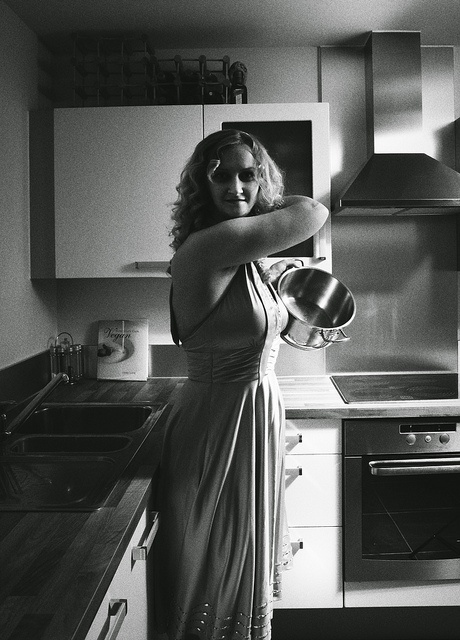Describe the objects in this image and their specific colors. I can see people in black, gray, lightgray, and darkgray tones, oven in black, gray, darkgray, and lightgray tones, sink in black, gray, and darkgray tones, sink in black, gray, and darkgray tones, and sink in black tones in this image. 